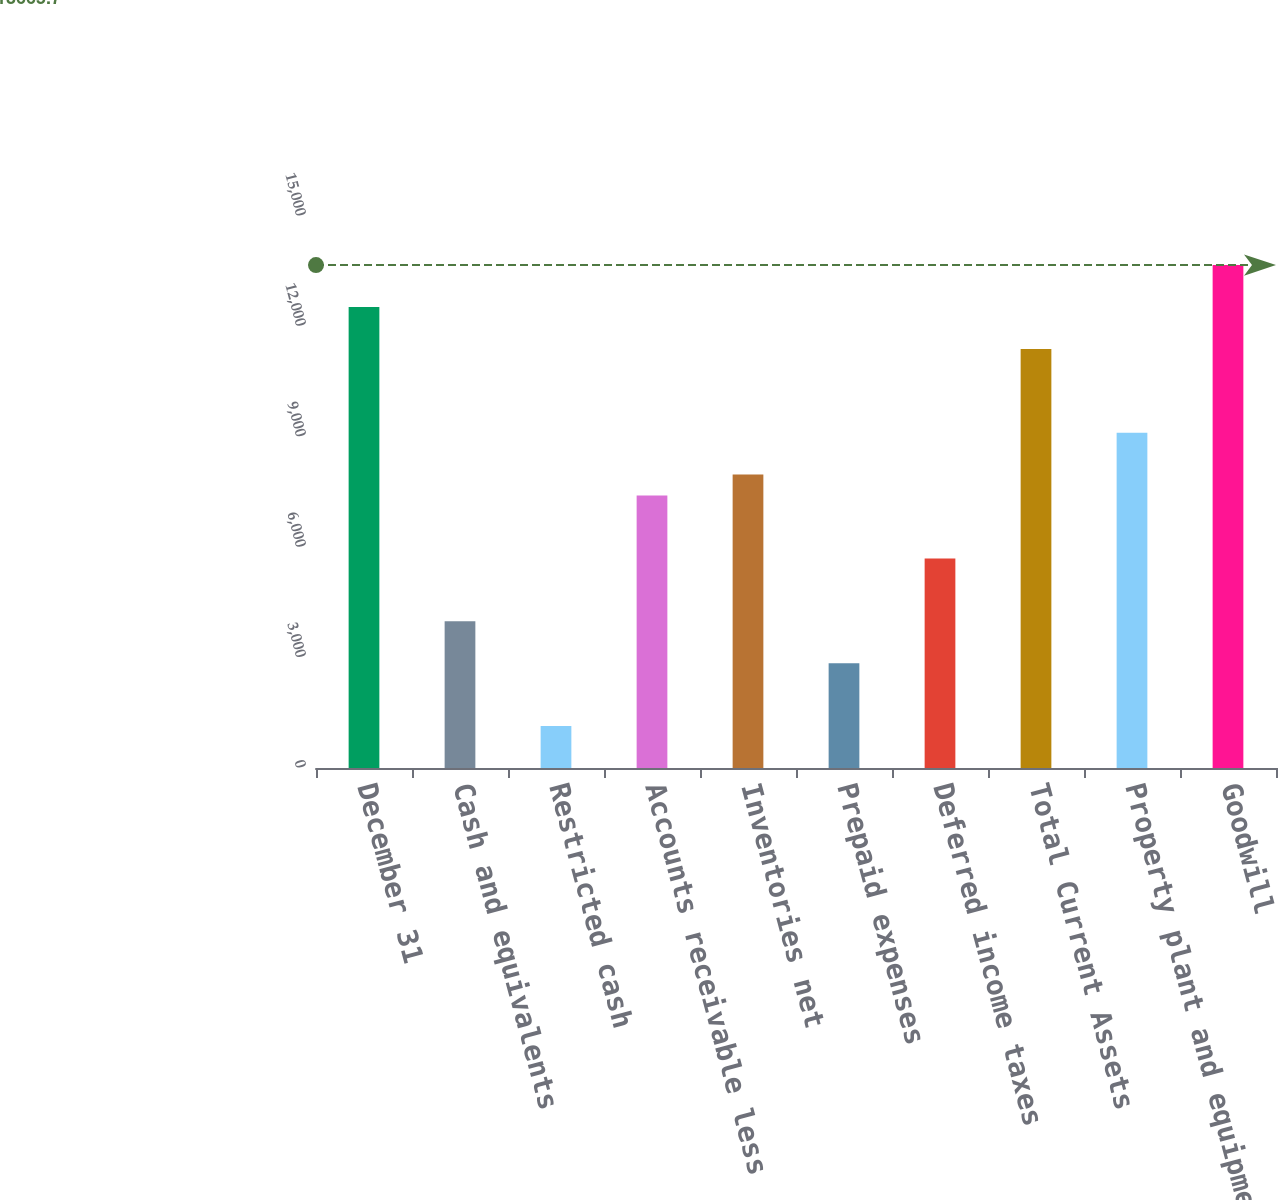<chart> <loc_0><loc_0><loc_500><loc_500><bar_chart><fcel>December 31<fcel>Cash and equivalents<fcel>Restricted cash<fcel>Accounts receivable less<fcel>Inventories net<fcel>Prepaid expenses<fcel>Deferred income taxes<fcel>Total Current Assets<fcel>Property plant and equipment<fcel>Goodwill<nl><fcel>12527.1<fcel>3987.6<fcel>1141.1<fcel>7403.4<fcel>7972.7<fcel>2849<fcel>5695.5<fcel>11388.5<fcel>9111.3<fcel>13665.7<nl></chart> 